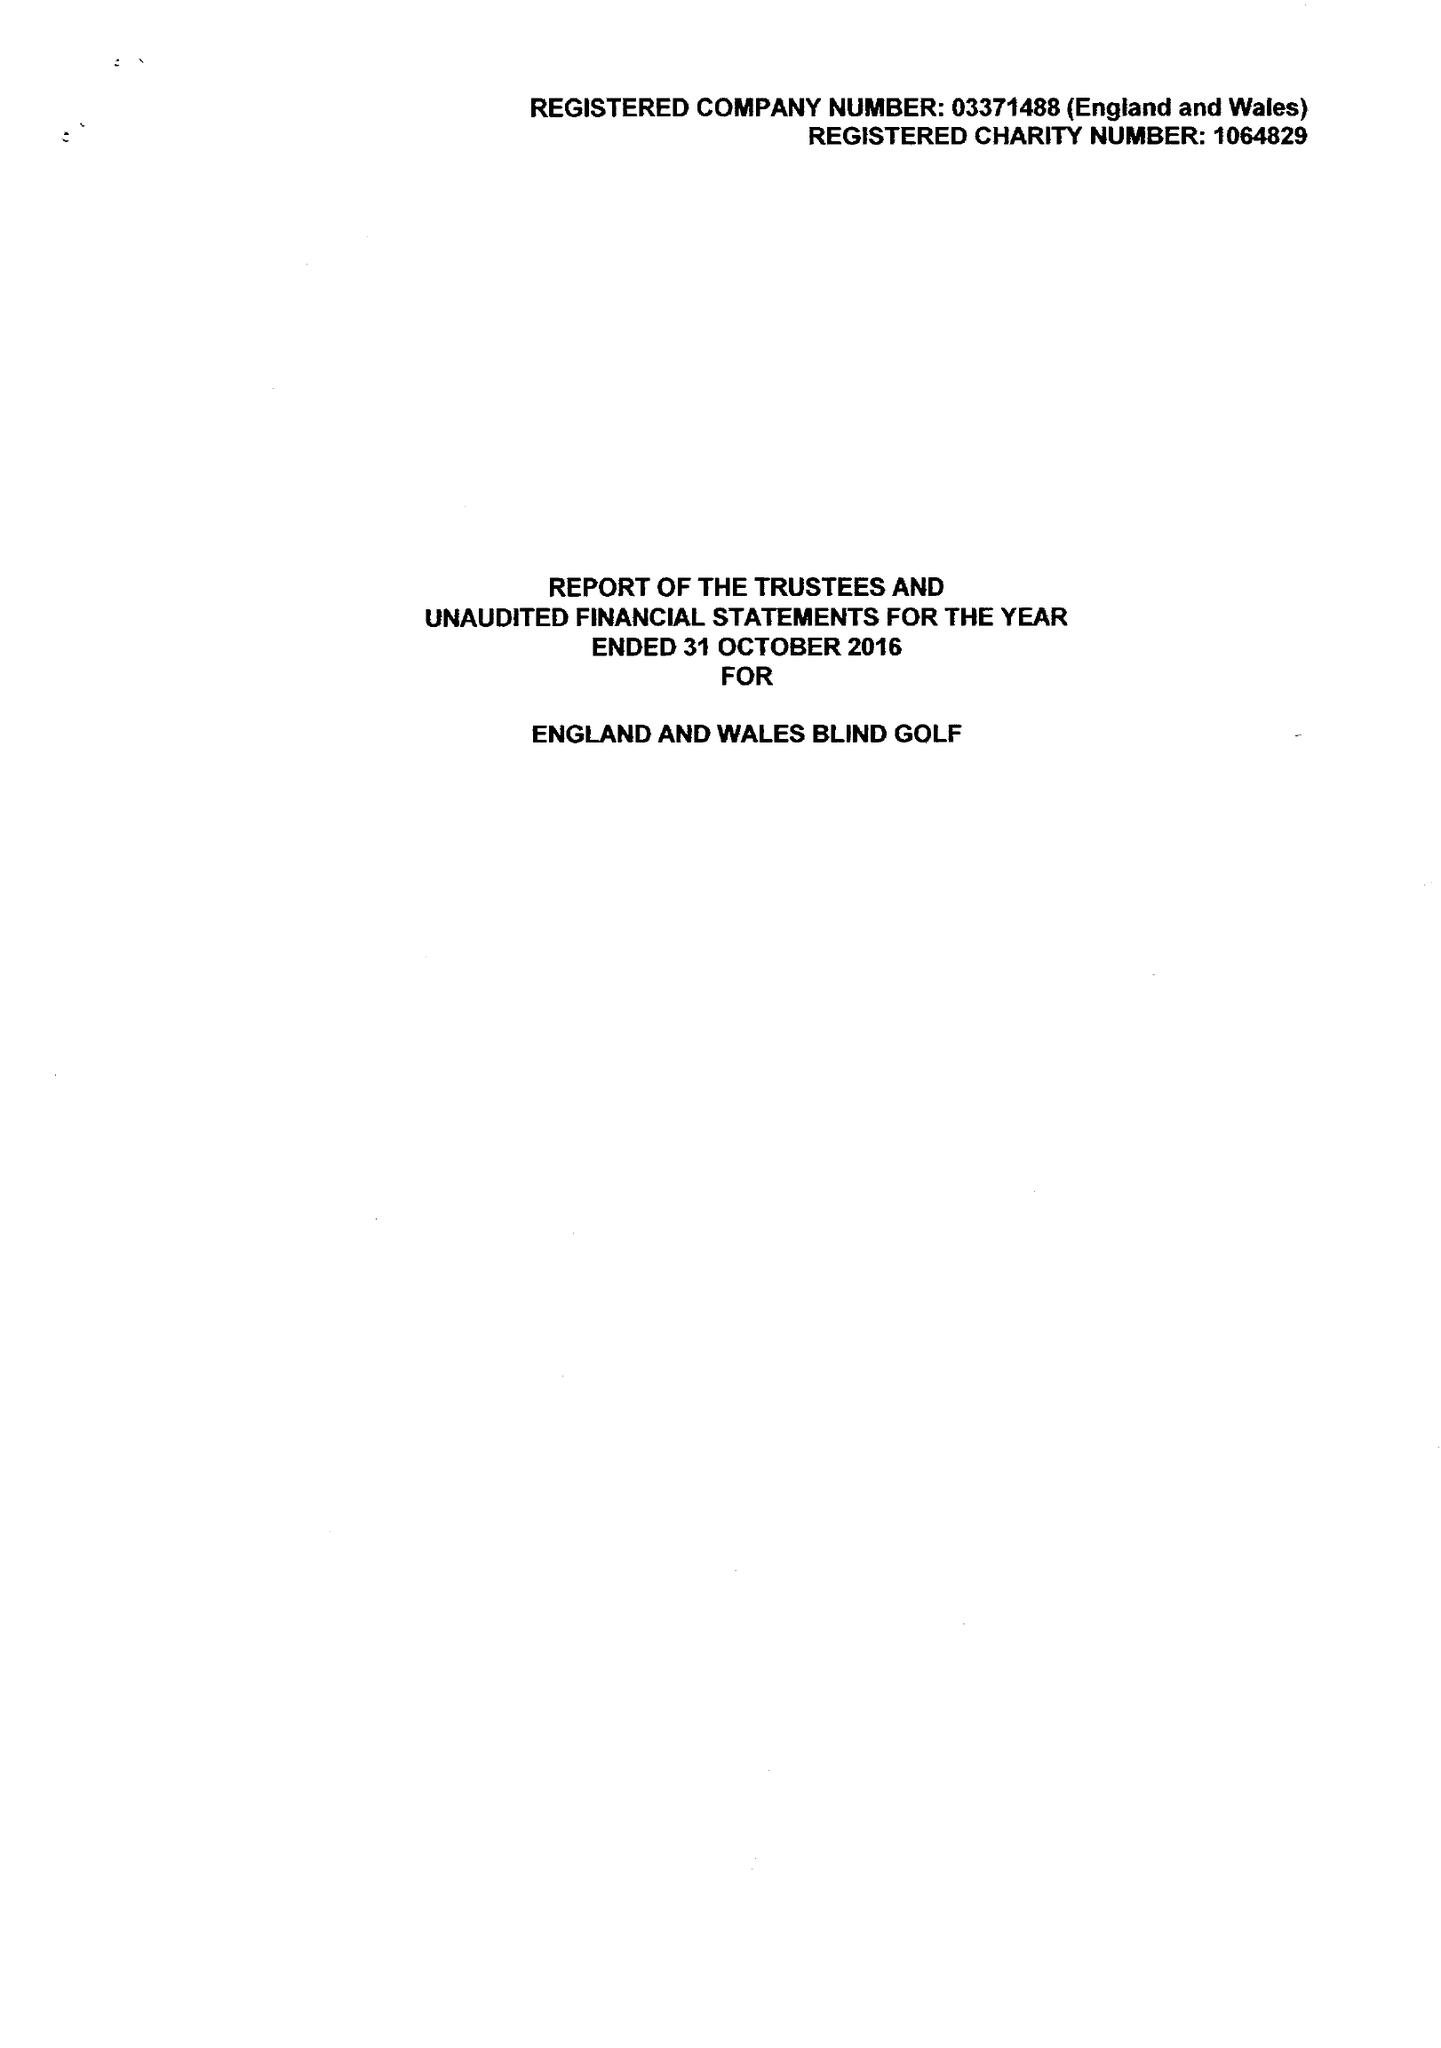What is the value for the address__post_town?
Answer the question using a single word or phrase. HAVANT 